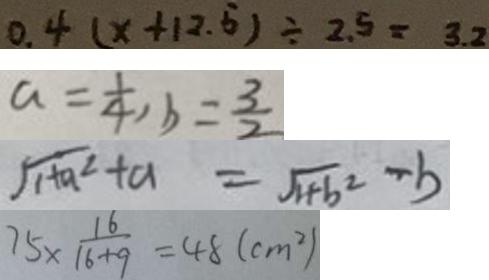<formula> <loc_0><loc_0><loc_500><loc_500>0 . 4 ( x + 1 2 . 5 ) \div 2 . 5 = 3 . 2 
 a = \frac { 1 } { 4 } , b = \frac { 3 } { 2 } 
 \sqrt { 1 + a ^ { 2 } } + a = \sqrt { 1 + b ^ { 2 } } - b 
 7 5 \times \frac { 1 6 } { 1 6 + 9 } = 4 8 ( c m ^ { 2 } )</formula> 